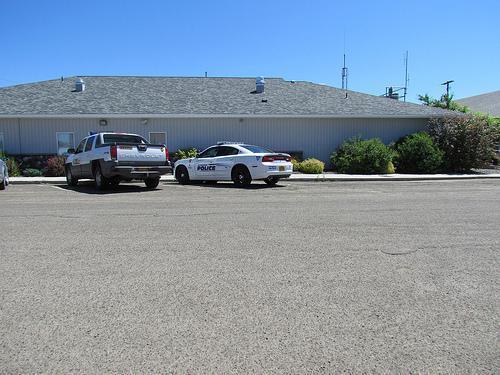How many vehicles can be seen?
Give a very brief answer. 2. 